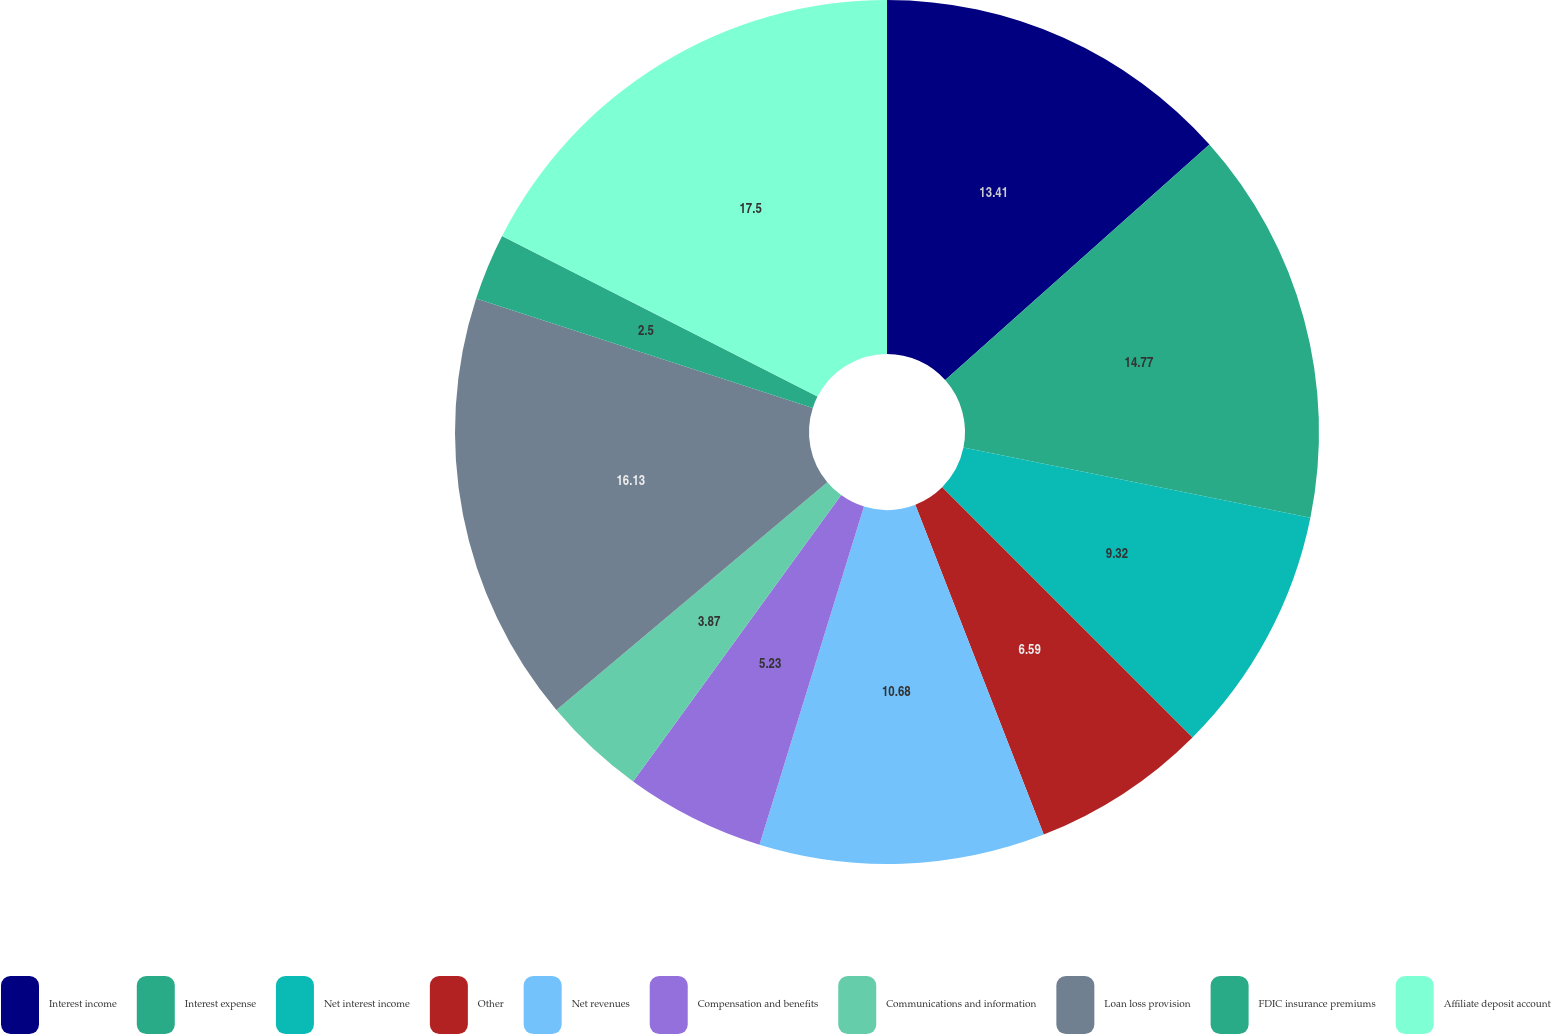Convert chart. <chart><loc_0><loc_0><loc_500><loc_500><pie_chart><fcel>Interest income<fcel>Interest expense<fcel>Net interest income<fcel>Other<fcel>Net revenues<fcel>Compensation and benefits<fcel>Communications and information<fcel>Loan loss provision<fcel>FDIC insurance premiums<fcel>Affiliate deposit account<nl><fcel>13.41%<fcel>14.77%<fcel>9.32%<fcel>6.59%<fcel>10.68%<fcel>5.23%<fcel>3.87%<fcel>16.13%<fcel>2.5%<fcel>17.5%<nl></chart> 